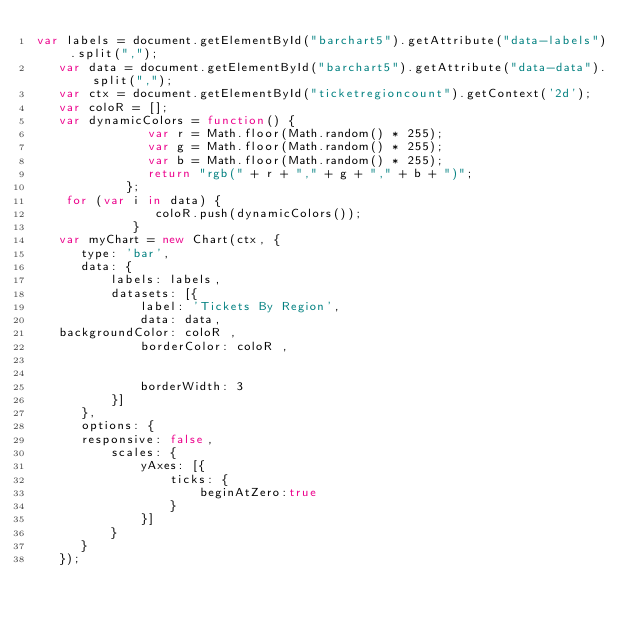Convert code to text. <code><loc_0><loc_0><loc_500><loc_500><_JavaScript_>var labels = document.getElementById("barchart5").getAttribute("data-labels").split(",");
   var data = document.getElementById("barchart5").getAttribute("data-data").split(",");
   var ctx = document.getElementById("ticketregioncount").getContext('2d');
   var coloR = [];
   var dynamicColors = function() {
               var r = Math.floor(Math.random() * 255);
               var g = Math.floor(Math.random() * 255);
               var b = Math.floor(Math.random() * 255);
               return "rgb(" + r + "," + g + "," + b + ")";
            };
    for (var i in data) {
                coloR.push(dynamicColors());
             }
   var myChart = new Chart(ctx, {
      type: 'bar',
      data: {
          labels: labels,
          datasets: [{
              label: 'Tickets By Region',
              data: data,
   backgroundColor: coloR ,
              borderColor: coloR ,


              borderWidth: 3
          }]
      },
      options: {
      responsive: false,
          scales: {
              yAxes: [{
                  ticks: {
                      beginAtZero:true
                  }
              }]
          }
      }
   });</code> 